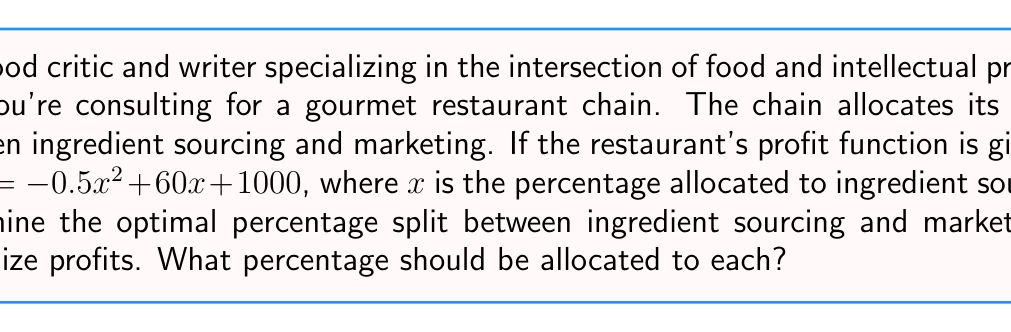Can you solve this math problem? To solve this problem, we'll follow these steps:

1) The profit function is a quadratic equation in the form $P(x) = -0.5x^2 + 60x + 1000$, where $x$ is the percentage allocated to ingredient sourcing.

2) To find the maximum profit, we need to find the vertex of this parabola. The x-coordinate of the vertex will give us the optimal percentage for ingredient sourcing.

3) For a quadratic function in the form $f(x) = ax^2 + bx + c$, the x-coordinate of the vertex is given by $x = -\frac{b}{2a}$.

4) In our case, $a = -0.5$ and $b = 60$. So:

   $$x = -\frac{60}{2(-0.5)} = -\frac{60}{-1} = 60$$

5) This means that 60% should be allocated to ingredient sourcing to maximize profits.

6) Since the total allocation must be 100%, the remaining 40% should be allocated to marketing.

7) To verify, we can calculate the second derivative:
   $$P''(x) = -1$$
   Since this is negative, we confirm that x = 60 gives a maximum, not a minimum.
Answer: The optimal allocation is 60% for ingredient sourcing and 40% for marketing. 